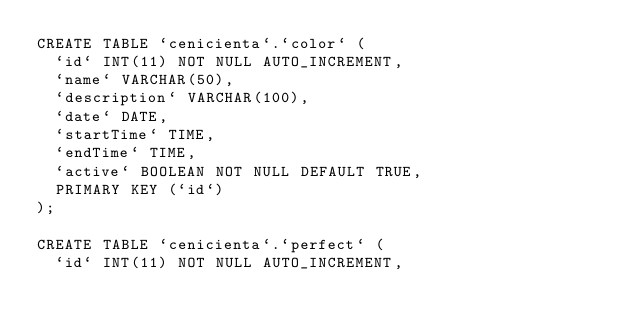Convert code to text. <code><loc_0><loc_0><loc_500><loc_500><_SQL_>CREATE TABLE `cenicienta`.`color` (
  `id` INT(11) NOT NULL AUTO_INCREMENT,
  `name` VARCHAR(50),
  `description` VARCHAR(100),
  `date` DATE,
  `startTime` TIME,
  `endTime` TIME,
  `active` BOOLEAN NOT NULL DEFAULT TRUE,
  PRIMARY KEY (`id`)
);

CREATE TABLE `cenicienta`.`perfect` (
  `id` INT(11) NOT NULL AUTO_INCREMENT,</code> 